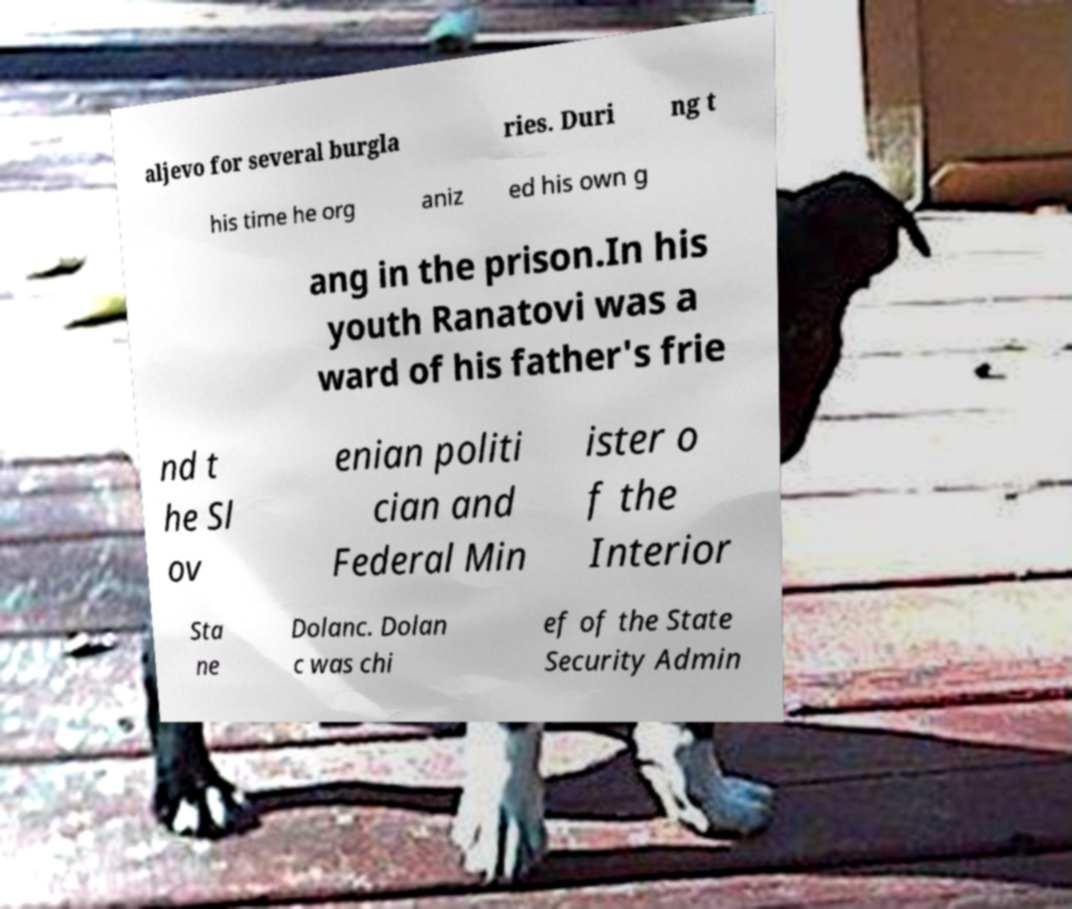For documentation purposes, I need the text within this image transcribed. Could you provide that? aljevo for several burgla ries. Duri ng t his time he org aniz ed his own g ang in the prison.In his youth Ranatovi was a ward of his father's frie nd t he Sl ov enian politi cian and Federal Min ister o f the Interior Sta ne Dolanc. Dolan c was chi ef of the State Security Admin 